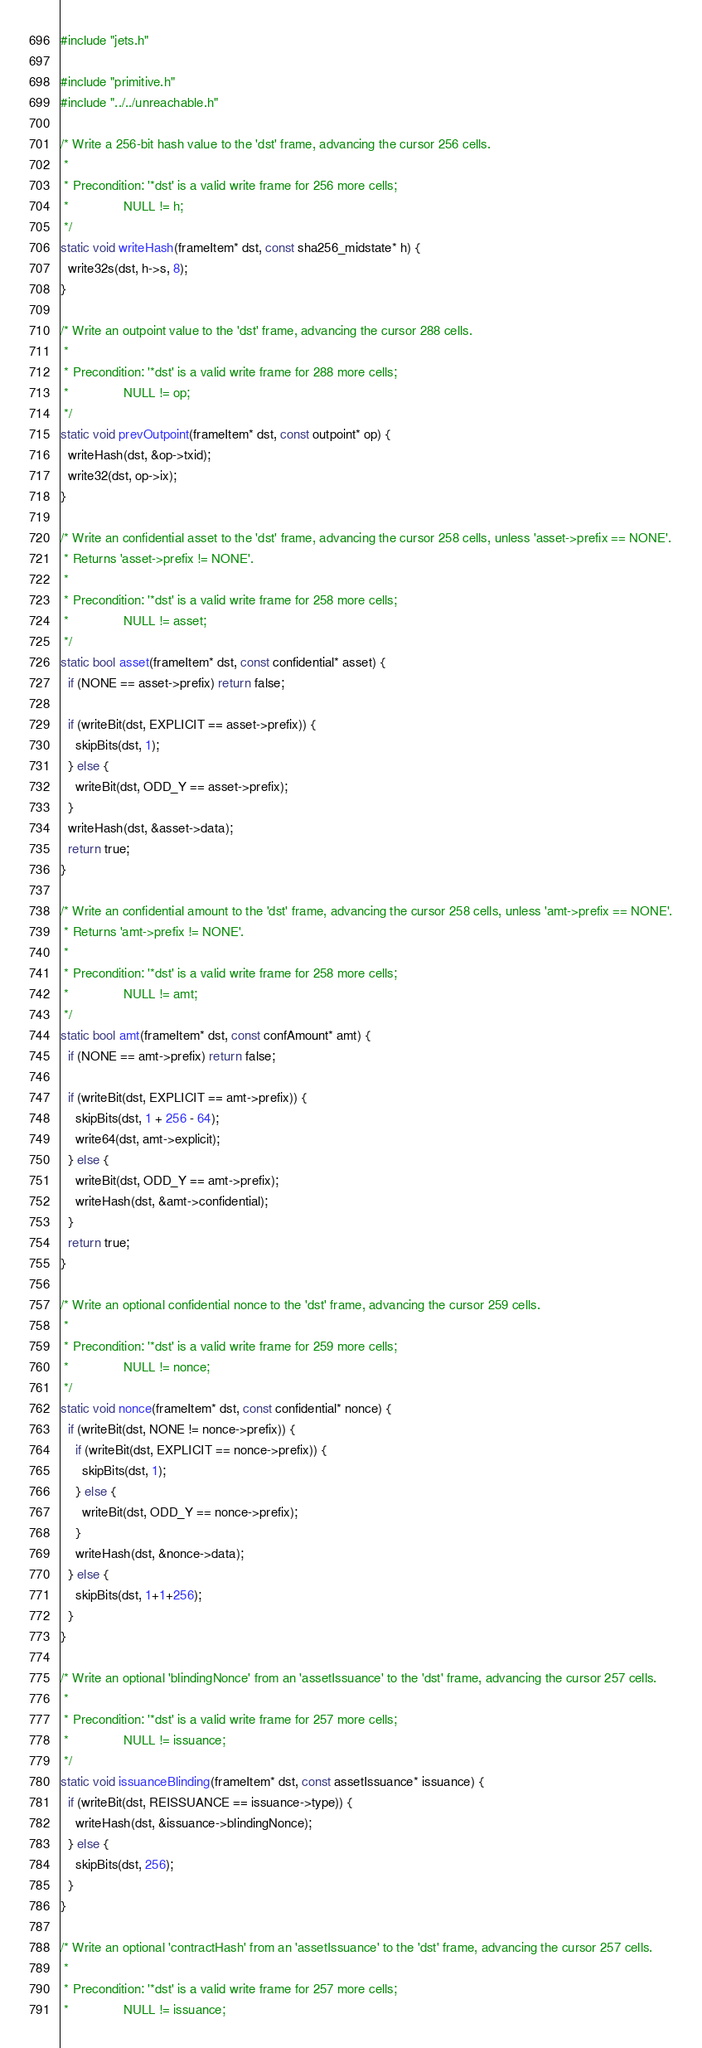<code> <loc_0><loc_0><loc_500><loc_500><_C_>#include "jets.h"

#include "primitive.h"
#include "../../unreachable.h"

/* Write a 256-bit hash value to the 'dst' frame, advancing the cursor 256 cells.
 *
 * Precondition: '*dst' is a valid write frame for 256 more cells;
 *               NULL != h;
 */
static void writeHash(frameItem* dst, const sha256_midstate* h) {
  write32s(dst, h->s, 8);
}

/* Write an outpoint value to the 'dst' frame, advancing the cursor 288 cells.
 *
 * Precondition: '*dst' is a valid write frame for 288 more cells;
 *               NULL != op;
 */
static void prevOutpoint(frameItem* dst, const outpoint* op) {
  writeHash(dst, &op->txid);
  write32(dst, op->ix);
}

/* Write an confidential asset to the 'dst' frame, advancing the cursor 258 cells, unless 'asset->prefix == NONE'.
 * Returns 'asset->prefix != NONE'.
 *
 * Precondition: '*dst' is a valid write frame for 258 more cells;
 *               NULL != asset;
 */
static bool asset(frameItem* dst, const confidential* asset) {
  if (NONE == asset->prefix) return false;

  if (writeBit(dst, EXPLICIT == asset->prefix)) {
    skipBits(dst, 1);
  } else {
    writeBit(dst, ODD_Y == asset->prefix);
  }
  writeHash(dst, &asset->data);
  return true;
}

/* Write an confidential amount to the 'dst' frame, advancing the cursor 258 cells, unless 'amt->prefix == NONE'.
 * Returns 'amt->prefix != NONE'.
 *
 * Precondition: '*dst' is a valid write frame for 258 more cells;
 *               NULL != amt;
 */
static bool amt(frameItem* dst, const confAmount* amt) {
  if (NONE == amt->prefix) return false;

  if (writeBit(dst, EXPLICIT == amt->prefix)) {
    skipBits(dst, 1 + 256 - 64);
    write64(dst, amt->explicit);
  } else {
    writeBit(dst, ODD_Y == amt->prefix);
    writeHash(dst, &amt->confidential);
  }
  return true;
}

/* Write an optional confidential nonce to the 'dst' frame, advancing the cursor 259 cells.
 *
 * Precondition: '*dst' is a valid write frame for 259 more cells;
 *               NULL != nonce;
 */
static void nonce(frameItem* dst, const confidential* nonce) {
  if (writeBit(dst, NONE != nonce->prefix)) {
    if (writeBit(dst, EXPLICIT == nonce->prefix)) {
      skipBits(dst, 1);
    } else {
      writeBit(dst, ODD_Y == nonce->prefix);
    }
    writeHash(dst, &nonce->data);
  } else {
    skipBits(dst, 1+1+256);
  }
}

/* Write an optional 'blindingNonce' from an 'assetIssuance' to the 'dst' frame, advancing the cursor 257 cells.
 *
 * Precondition: '*dst' is a valid write frame for 257 more cells;
 *               NULL != issuance;
 */
static void issuanceBlinding(frameItem* dst, const assetIssuance* issuance) {
  if (writeBit(dst, REISSUANCE == issuance->type)) {
    writeHash(dst, &issuance->blindingNonce);
  } else {
    skipBits(dst, 256);
  }
}

/* Write an optional 'contractHash' from an 'assetIssuance' to the 'dst' frame, advancing the cursor 257 cells.
 *
 * Precondition: '*dst' is a valid write frame for 257 more cells;
 *               NULL != issuance;</code> 